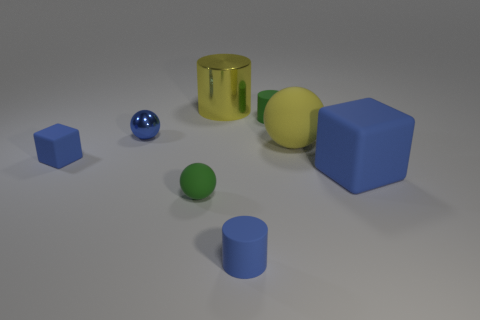Subtract all tiny balls. How many balls are left? 1 Add 1 metallic balls. How many objects exist? 9 Subtract all green cylinders. How many cylinders are left? 2 Subtract 2 blocks. How many blocks are left? 0 Subtract all cylinders. How many objects are left? 5 Add 7 tiny blue shiny balls. How many tiny blue shiny balls exist? 8 Subtract 1 yellow cylinders. How many objects are left? 7 Subtract all yellow cubes. Subtract all blue spheres. How many cubes are left? 2 Subtract all blue blocks. How many blue spheres are left? 1 Subtract all brown blocks. Subtract all green rubber cylinders. How many objects are left? 7 